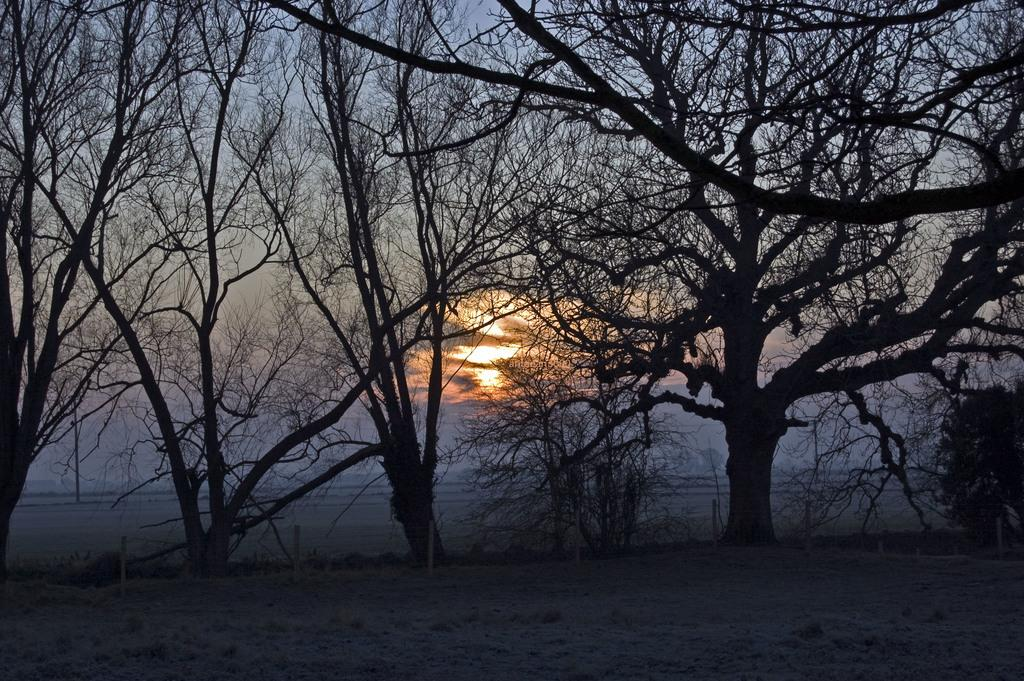What type of vegetation can be seen in the image? There are trees in the image. What part of the natural environment is visible in the image? The sky is visible in the background of the image. What type of nose can be seen on the crow in the image? There is no crow present in the image, so it is not possible to determine the type of nose on the crow. 